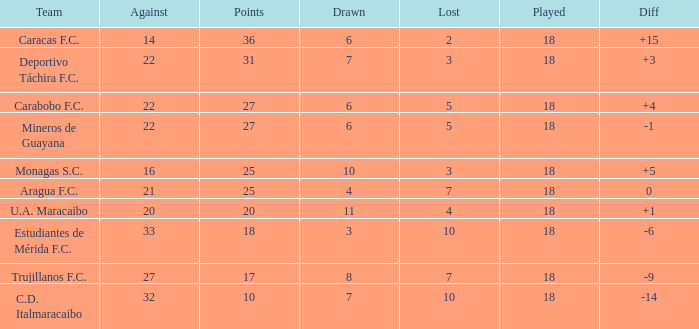What is the lowest number of points of any team with less than 6 draws and less than 18 matches played? None. 